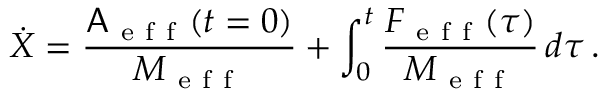<formula> <loc_0><loc_0><loc_500><loc_500>\dot { X } = \frac { A _ { e f f } ( t = 0 ) } { M _ { e f f } } + \int _ { 0 } ^ { t } \frac { F _ { e f f } ( \tau ) } { M _ { e f f } } \, d \tau \, .</formula> 